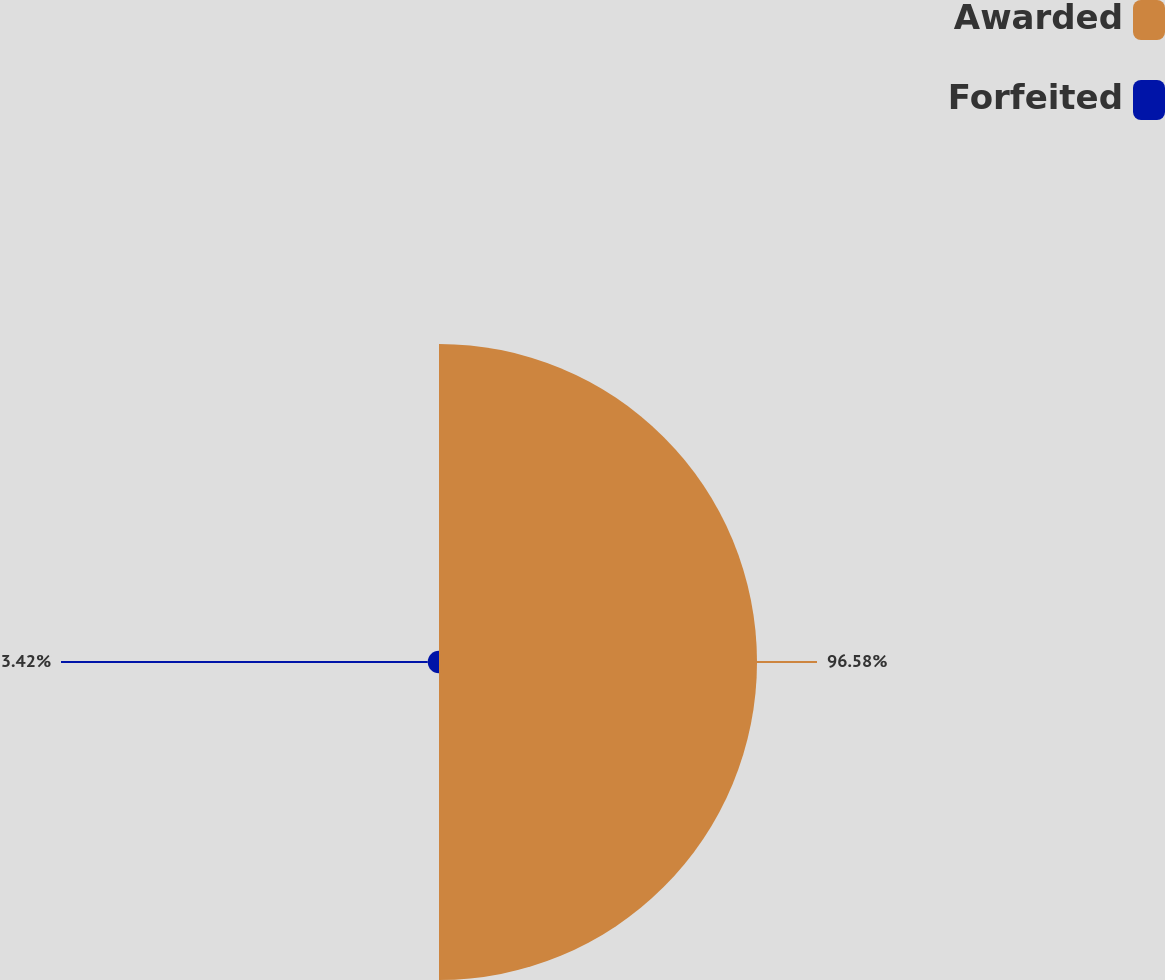<chart> <loc_0><loc_0><loc_500><loc_500><pie_chart><fcel>Awarded<fcel>Forfeited<nl><fcel>96.58%<fcel>3.42%<nl></chart> 